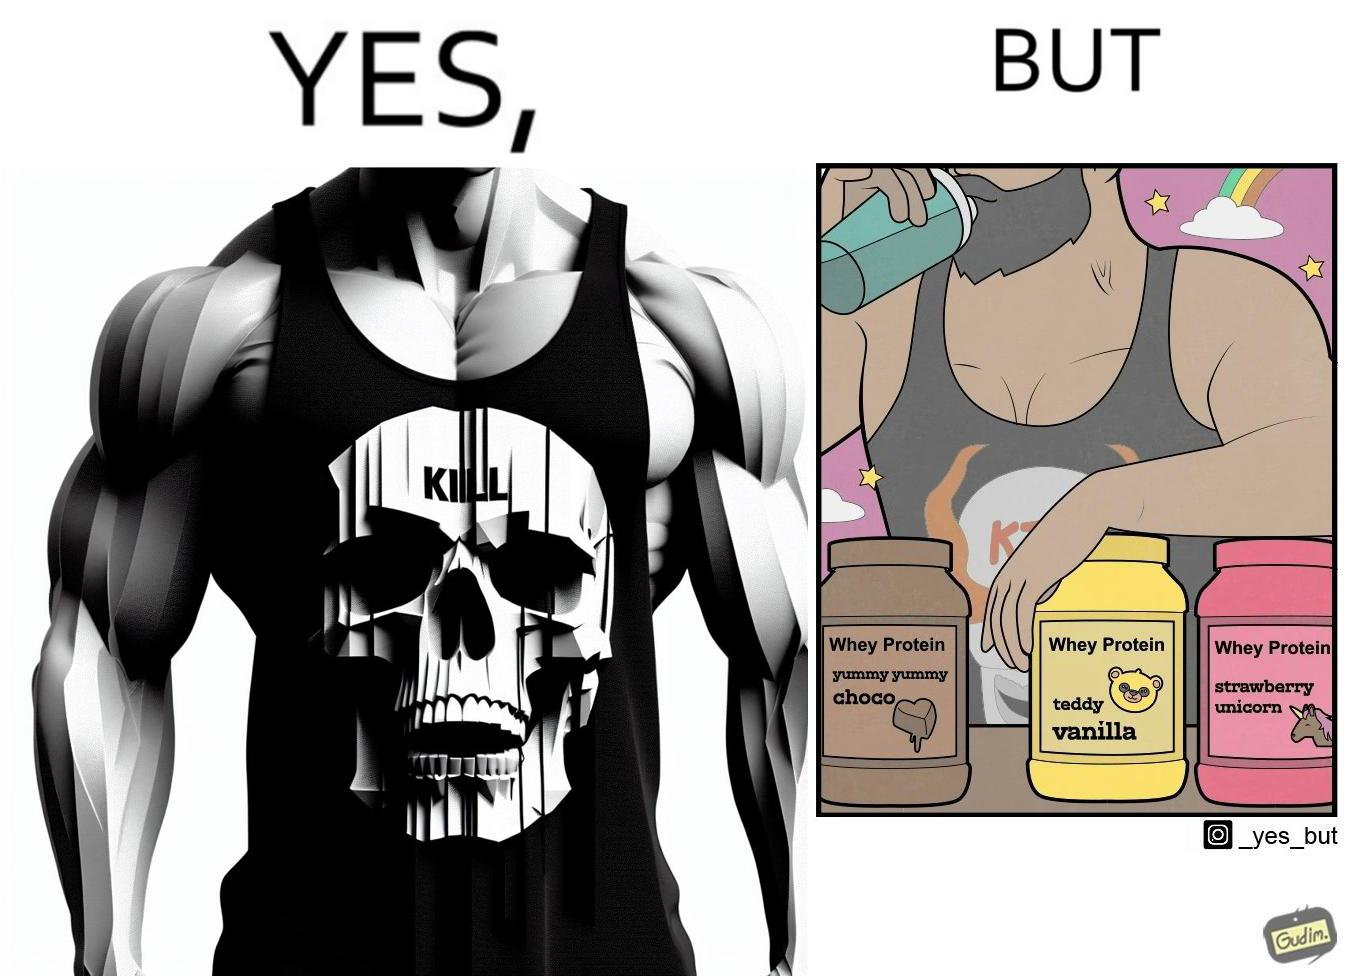What is shown in the left half versus the right half of this image? In the left part of the image: a well-built person wearing a tank top with the word "KILL" on an image of a skull. In the right part of the image: a well-built person consuming whey protein from one of three flavours. 